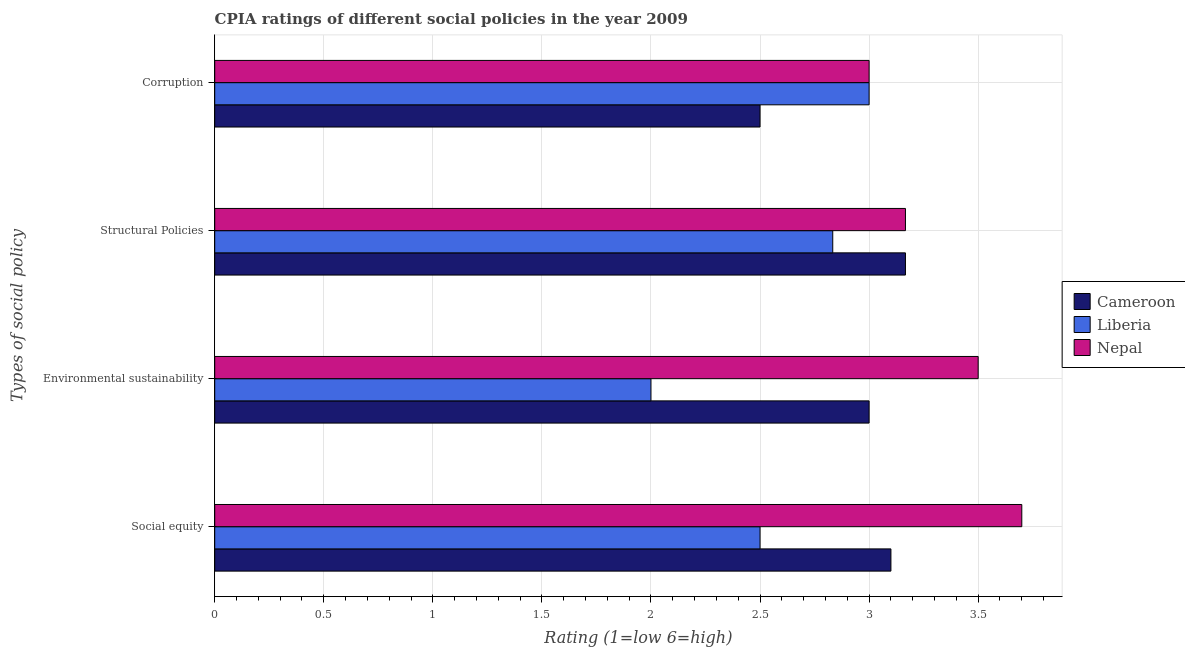How many groups of bars are there?
Give a very brief answer. 4. Are the number of bars per tick equal to the number of legend labels?
Keep it short and to the point. Yes. Are the number of bars on each tick of the Y-axis equal?
Offer a terse response. Yes. How many bars are there on the 1st tick from the top?
Your response must be concise. 3. How many bars are there on the 1st tick from the bottom?
Offer a very short reply. 3. What is the label of the 2nd group of bars from the top?
Provide a succinct answer. Structural Policies. Across all countries, what is the maximum cpia rating of structural policies?
Your answer should be very brief. 3.17. Across all countries, what is the minimum cpia rating of environmental sustainability?
Offer a terse response. 2. In which country was the cpia rating of structural policies maximum?
Your answer should be compact. Cameroon. In which country was the cpia rating of corruption minimum?
Offer a terse response. Cameroon. What is the difference between the cpia rating of structural policies in Liberia and that in Cameroon?
Offer a terse response. -0.33. What is the average cpia rating of structural policies per country?
Keep it short and to the point. 3.06. What is the difference between the cpia rating of environmental sustainability and cpia rating of social equity in Liberia?
Keep it short and to the point. -0.5. What is the ratio of the cpia rating of corruption in Cameroon to that in Liberia?
Your answer should be compact. 0.83. What is the difference between the highest and the second highest cpia rating of environmental sustainability?
Offer a very short reply. 0.5. What is the difference between the highest and the lowest cpia rating of structural policies?
Offer a terse response. 0.33. In how many countries, is the cpia rating of social equity greater than the average cpia rating of social equity taken over all countries?
Make the answer very short. 1. Is it the case that in every country, the sum of the cpia rating of social equity and cpia rating of corruption is greater than the sum of cpia rating of environmental sustainability and cpia rating of structural policies?
Offer a terse response. No. What does the 3rd bar from the top in Social equity represents?
Keep it short and to the point. Cameroon. What does the 1st bar from the bottom in Structural Policies represents?
Provide a succinct answer. Cameroon. Is it the case that in every country, the sum of the cpia rating of social equity and cpia rating of environmental sustainability is greater than the cpia rating of structural policies?
Make the answer very short. Yes. What is the difference between two consecutive major ticks on the X-axis?
Your response must be concise. 0.5. Does the graph contain any zero values?
Keep it short and to the point. No. Where does the legend appear in the graph?
Ensure brevity in your answer.  Center right. How many legend labels are there?
Offer a very short reply. 3. How are the legend labels stacked?
Your answer should be very brief. Vertical. What is the title of the graph?
Offer a very short reply. CPIA ratings of different social policies in the year 2009. Does "Iran" appear as one of the legend labels in the graph?
Provide a short and direct response. No. What is the label or title of the Y-axis?
Provide a succinct answer. Types of social policy. What is the Rating (1=low 6=high) of Cameroon in Social equity?
Ensure brevity in your answer.  3.1. What is the Rating (1=low 6=high) of Liberia in Social equity?
Your answer should be very brief. 2.5. What is the Rating (1=low 6=high) of Nepal in Social equity?
Ensure brevity in your answer.  3.7. What is the Rating (1=low 6=high) in Cameroon in Environmental sustainability?
Give a very brief answer. 3. What is the Rating (1=low 6=high) of Cameroon in Structural Policies?
Keep it short and to the point. 3.17. What is the Rating (1=low 6=high) in Liberia in Structural Policies?
Make the answer very short. 2.83. What is the Rating (1=low 6=high) in Nepal in Structural Policies?
Your answer should be compact. 3.17. What is the Rating (1=low 6=high) in Liberia in Corruption?
Make the answer very short. 3. Across all Types of social policy, what is the maximum Rating (1=low 6=high) of Cameroon?
Keep it short and to the point. 3.17. Across all Types of social policy, what is the maximum Rating (1=low 6=high) in Liberia?
Make the answer very short. 3. Across all Types of social policy, what is the maximum Rating (1=low 6=high) in Nepal?
Your response must be concise. 3.7. Across all Types of social policy, what is the minimum Rating (1=low 6=high) of Cameroon?
Offer a terse response. 2.5. Across all Types of social policy, what is the minimum Rating (1=low 6=high) in Liberia?
Your answer should be compact. 2. Across all Types of social policy, what is the minimum Rating (1=low 6=high) in Nepal?
Make the answer very short. 3. What is the total Rating (1=low 6=high) in Cameroon in the graph?
Keep it short and to the point. 11.77. What is the total Rating (1=low 6=high) of Liberia in the graph?
Make the answer very short. 10.33. What is the total Rating (1=low 6=high) in Nepal in the graph?
Keep it short and to the point. 13.37. What is the difference between the Rating (1=low 6=high) in Liberia in Social equity and that in Environmental sustainability?
Offer a terse response. 0.5. What is the difference between the Rating (1=low 6=high) in Nepal in Social equity and that in Environmental sustainability?
Make the answer very short. 0.2. What is the difference between the Rating (1=low 6=high) of Cameroon in Social equity and that in Structural Policies?
Keep it short and to the point. -0.07. What is the difference between the Rating (1=low 6=high) in Nepal in Social equity and that in Structural Policies?
Provide a succinct answer. 0.53. What is the difference between the Rating (1=low 6=high) of Cameroon in Social equity and that in Corruption?
Offer a terse response. 0.6. What is the difference between the Rating (1=low 6=high) in Liberia in Social equity and that in Corruption?
Offer a very short reply. -0.5. What is the difference between the Rating (1=low 6=high) in Nepal in Social equity and that in Corruption?
Your response must be concise. 0.7. What is the difference between the Rating (1=low 6=high) in Cameroon in Environmental sustainability and that in Structural Policies?
Give a very brief answer. -0.17. What is the difference between the Rating (1=low 6=high) of Liberia in Environmental sustainability and that in Structural Policies?
Your answer should be compact. -0.83. What is the difference between the Rating (1=low 6=high) in Nepal in Environmental sustainability and that in Structural Policies?
Provide a short and direct response. 0.33. What is the difference between the Rating (1=low 6=high) in Cameroon in Environmental sustainability and that in Corruption?
Your response must be concise. 0.5. What is the difference between the Rating (1=low 6=high) of Liberia in Environmental sustainability and that in Corruption?
Offer a terse response. -1. What is the difference between the Rating (1=low 6=high) in Nepal in Environmental sustainability and that in Corruption?
Your response must be concise. 0.5. What is the difference between the Rating (1=low 6=high) in Cameroon in Structural Policies and that in Corruption?
Keep it short and to the point. 0.67. What is the difference between the Rating (1=low 6=high) in Nepal in Structural Policies and that in Corruption?
Your response must be concise. 0.17. What is the difference between the Rating (1=low 6=high) in Cameroon in Social equity and the Rating (1=low 6=high) in Liberia in Environmental sustainability?
Offer a terse response. 1.1. What is the difference between the Rating (1=low 6=high) in Liberia in Social equity and the Rating (1=low 6=high) in Nepal in Environmental sustainability?
Your answer should be compact. -1. What is the difference between the Rating (1=low 6=high) in Cameroon in Social equity and the Rating (1=low 6=high) in Liberia in Structural Policies?
Offer a very short reply. 0.27. What is the difference between the Rating (1=low 6=high) in Cameroon in Social equity and the Rating (1=low 6=high) in Nepal in Structural Policies?
Give a very brief answer. -0.07. What is the difference between the Rating (1=low 6=high) of Cameroon in Social equity and the Rating (1=low 6=high) of Nepal in Corruption?
Your answer should be very brief. 0.1. What is the difference between the Rating (1=low 6=high) in Liberia in Social equity and the Rating (1=low 6=high) in Nepal in Corruption?
Provide a succinct answer. -0.5. What is the difference between the Rating (1=low 6=high) in Liberia in Environmental sustainability and the Rating (1=low 6=high) in Nepal in Structural Policies?
Give a very brief answer. -1.17. What is the difference between the Rating (1=low 6=high) in Liberia in Environmental sustainability and the Rating (1=low 6=high) in Nepal in Corruption?
Your response must be concise. -1. What is the difference between the Rating (1=low 6=high) in Liberia in Structural Policies and the Rating (1=low 6=high) in Nepal in Corruption?
Your answer should be very brief. -0.17. What is the average Rating (1=low 6=high) in Cameroon per Types of social policy?
Make the answer very short. 2.94. What is the average Rating (1=low 6=high) in Liberia per Types of social policy?
Give a very brief answer. 2.58. What is the average Rating (1=low 6=high) of Nepal per Types of social policy?
Ensure brevity in your answer.  3.34. What is the difference between the Rating (1=low 6=high) of Cameroon and Rating (1=low 6=high) of Liberia in Social equity?
Your response must be concise. 0.6. What is the difference between the Rating (1=low 6=high) of Cameroon and Rating (1=low 6=high) of Liberia in Environmental sustainability?
Provide a short and direct response. 1. What is the difference between the Rating (1=low 6=high) in Liberia and Rating (1=low 6=high) in Nepal in Environmental sustainability?
Provide a short and direct response. -1.5. What is the difference between the Rating (1=low 6=high) of Cameroon and Rating (1=low 6=high) of Nepal in Corruption?
Keep it short and to the point. -0.5. What is the difference between the Rating (1=low 6=high) in Liberia and Rating (1=low 6=high) in Nepal in Corruption?
Your answer should be very brief. 0. What is the ratio of the Rating (1=low 6=high) of Cameroon in Social equity to that in Environmental sustainability?
Make the answer very short. 1.03. What is the ratio of the Rating (1=low 6=high) in Liberia in Social equity to that in Environmental sustainability?
Give a very brief answer. 1.25. What is the ratio of the Rating (1=low 6=high) of Nepal in Social equity to that in Environmental sustainability?
Provide a succinct answer. 1.06. What is the ratio of the Rating (1=low 6=high) of Cameroon in Social equity to that in Structural Policies?
Give a very brief answer. 0.98. What is the ratio of the Rating (1=low 6=high) in Liberia in Social equity to that in Structural Policies?
Give a very brief answer. 0.88. What is the ratio of the Rating (1=low 6=high) of Nepal in Social equity to that in Structural Policies?
Your answer should be very brief. 1.17. What is the ratio of the Rating (1=low 6=high) in Cameroon in Social equity to that in Corruption?
Ensure brevity in your answer.  1.24. What is the ratio of the Rating (1=low 6=high) in Nepal in Social equity to that in Corruption?
Give a very brief answer. 1.23. What is the ratio of the Rating (1=low 6=high) in Cameroon in Environmental sustainability to that in Structural Policies?
Provide a short and direct response. 0.95. What is the ratio of the Rating (1=low 6=high) in Liberia in Environmental sustainability to that in Structural Policies?
Ensure brevity in your answer.  0.71. What is the ratio of the Rating (1=low 6=high) of Nepal in Environmental sustainability to that in Structural Policies?
Provide a succinct answer. 1.11. What is the ratio of the Rating (1=low 6=high) in Cameroon in Environmental sustainability to that in Corruption?
Give a very brief answer. 1.2. What is the ratio of the Rating (1=low 6=high) in Liberia in Environmental sustainability to that in Corruption?
Offer a terse response. 0.67. What is the ratio of the Rating (1=low 6=high) in Nepal in Environmental sustainability to that in Corruption?
Offer a very short reply. 1.17. What is the ratio of the Rating (1=low 6=high) of Cameroon in Structural Policies to that in Corruption?
Offer a terse response. 1.27. What is the ratio of the Rating (1=low 6=high) of Nepal in Structural Policies to that in Corruption?
Your response must be concise. 1.06. What is the difference between the highest and the second highest Rating (1=low 6=high) of Cameroon?
Give a very brief answer. 0.07. What is the difference between the highest and the lowest Rating (1=low 6=high) in Cameroon?
Offer a terse response. 0.67. What is the difference between the highest and the lowest Rating (1=low 6=high) in Liberia?
Give a very brief answer. 1. 